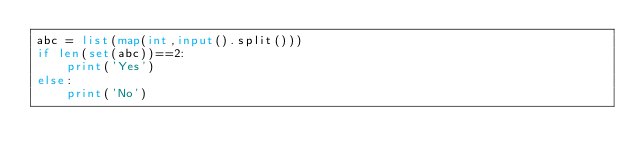Convert code to text. <code><loc_0><loc_0><loc_500><loc_500><_Python_>abc = list(map(int,input().split()))
if len(set(abc))==2:
    print('Yes')
else:
    print('No')</code> 